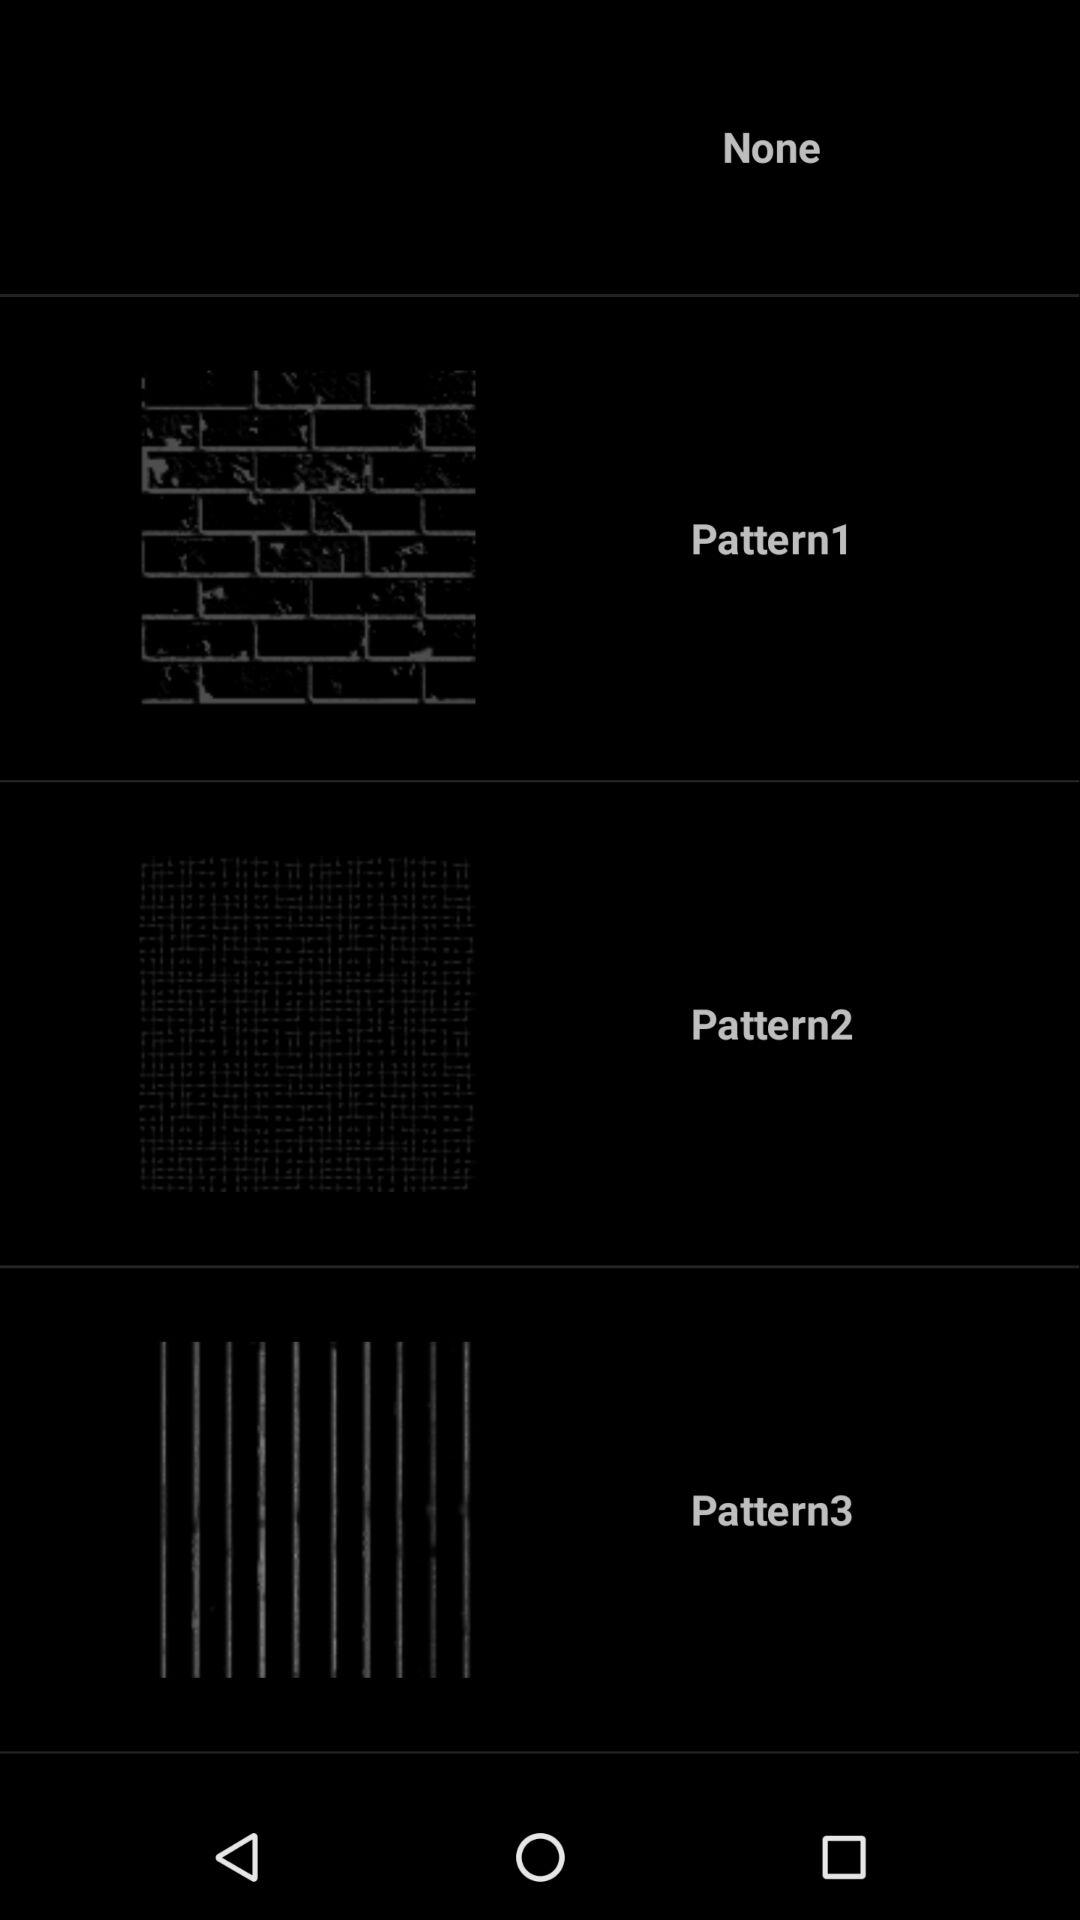How many patterns are there?
Answer the question using a single word or phrase. 3 